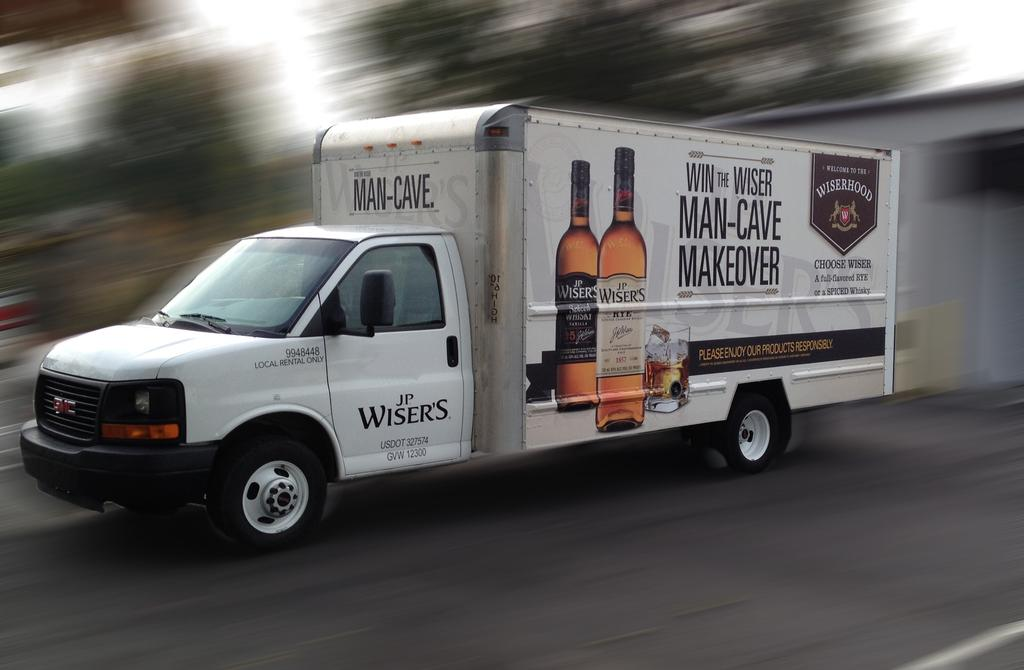<image>
Render a clear and concise summary of the photo. A J.P. Wisers truck with an image of Wiser bottles on the side of the truck. 